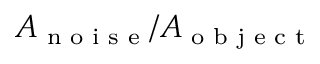Convert formula to latex. <formula><loc_0><loc_0><loc_500><loc_500>A _ { n o i s e } / A _ { o b j e c t }</formula> 